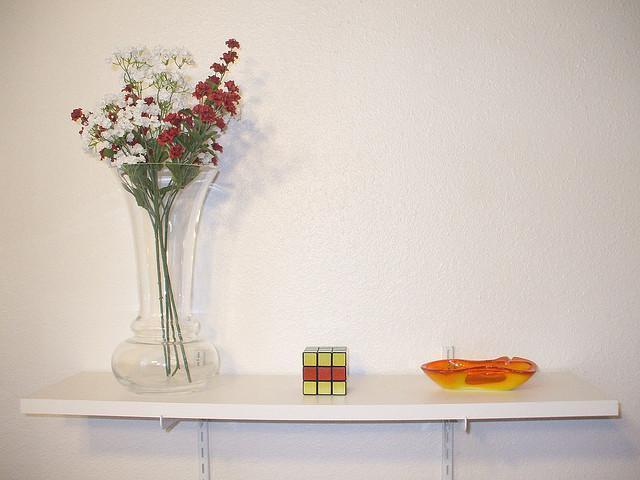How many objects are on the shelf?
Give a very brief answer. 3. 